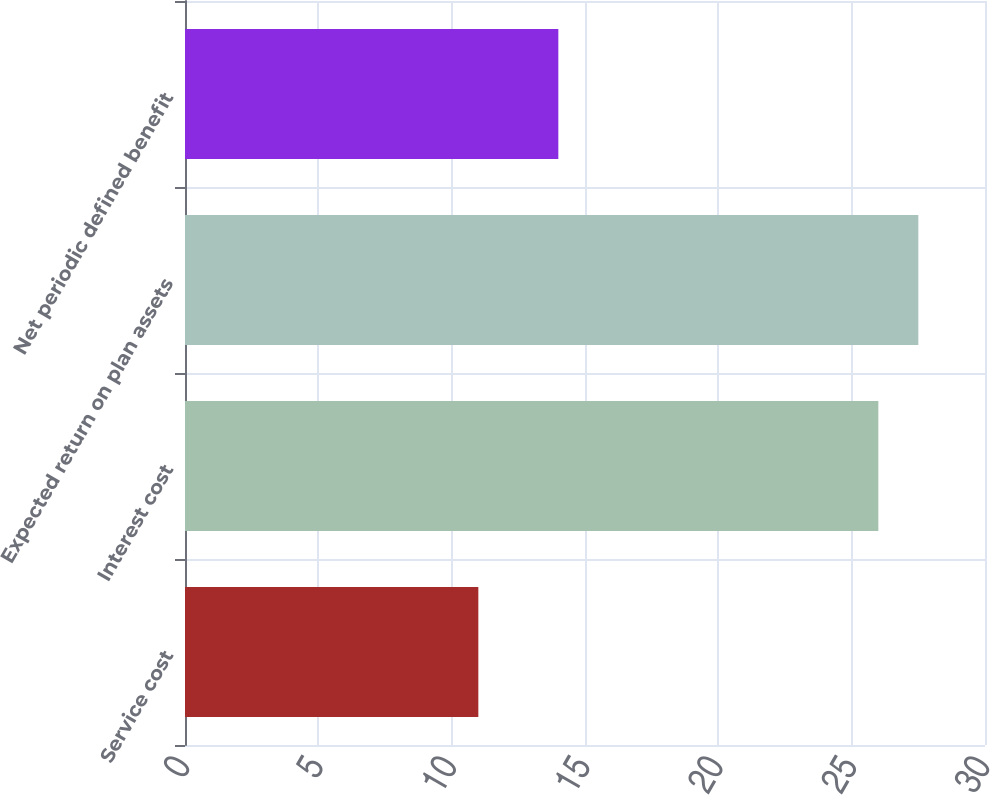<chart> <loc_0><loc_0><loc_500><loc_500><bar_chart><fcel>Service cost<fcel>Interest cost<fcel>Expected return on plan assets<fcel>Net periodic defined benefit<nl><fcel>11<fcel>26<fcel>27.5<fcel>14<nl></chart> 